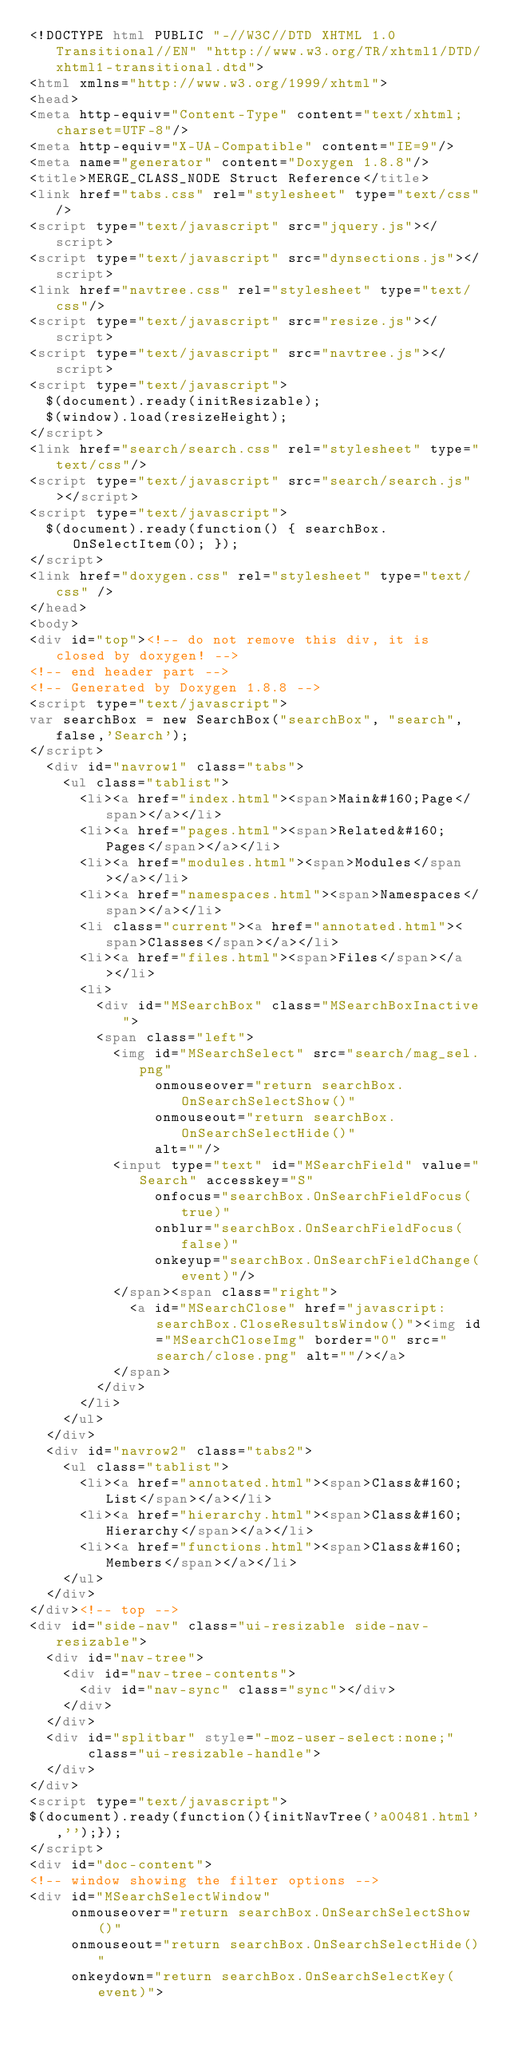Convert code to text. <code><loc_0><loc_0><loc_500><loc_500><_HTML_><!DOCTYPE html PUBLIC "-//W3C//DTD XHTML 1.0 Transitional//EN" "http://www.w3.org/TR/xhtml1/DTD/xhtml1-transitional.dtd">
<html xmlns="http://www.w3.org/1999/xhtml">
<head>
<meta http-equiv="Content-Type" content="text/xhtml;charset=UTF-8"/>
<meta http-equiv="X-UA-Compatible" content="IE=9"/>
<meta name="generator" content="Doxygen 1.8.8"/>
<title>MERGE_CLASS_NODE Struct Reference</title>
<link href="tabs.css" rel="stylesheet" type="text/css"/>
<script type="text/javascript" src="jquery.js"></script>
<script type="text/javascript" src="dynsections.js"></script>
<link href="navtree.css" rel="stylesheet" type="text/css"/>
<script type="text/javascript" src="resize.js"></script>
<script type="text/javascript" src="navtree.js"></script>
<script type="text/javascript">
  $(document).ready(initResizable);
  $(window).load(resizeHeight);
</script>
<link href="search/search.css" rel="stylesheet" type="text/css"/>
<script type="text/javascript" src="search/search.js"></script>
<script type="text/javascript">
  $(document).ready(function() { searchBox.OnSelectItem(0); });
</script>
<link href="doxygen.css" rel="stylesheet" type="text/css" />
</head>
<body>
<div id="top"><!-- do not remove this div, it is closed by doxygen! -->
<!-- end header part -->
<!-- Generated by Doxygen 1.8.8 -->
<script type="text/javascript">
var searchBox = new SearchBox("searchBox", "search",false,'Search');
</script>
  <div id="navrow1" class="tabs">
    <ul class="tablist">
      <li><a href="index.html"><span>Main&#160;Page</span></a></li>
      <li><a href="pages.html"><span>Related&#160;Pages</span></a></li>
      <li><a href="modules.html"><span>Modules</span></a></li>
      <li><a href="namespaces.html"><span>Namespaces</span></a></li>
      <li class="current"><a href="annotated.html"><span>Classes</span></a></li>
      <li><a href="files.html"><span>Files</span></a></li>
      <li>
        <div id="MSearchBox" class="MSearchBoxInactive">
        <span class="left">
          <img id="MSearchSelect" src="search/mag_sel.png"
               onmouseover="return searchBox.OnSearchSelectShow()"
               onmouseout="return searchBox.OnSearchSelectHide()"
               alt=""/>
          <input type="text" id="MSearchField" value="Search" accesskey="S"
               onfocus="searchBox.OnSearchFieldFocus(true)" 
               onblur="searchBox.OnSearchFieldFocus(false)" 
               onkeyup="searchBox.OnSearchFieldChange(event)"/>
          </span><span class="right">
            <a id="MSearchClose" href="javascript:searchBox.CloseResultsWindow()"><img id="MSearchCloseImg" border="0" src="search/close.png" alt=""/></a>
          </span>
        </div>
      </li>
    </ul>
  </div>
  <div id="navrow2" class="tabs2">
    <ul class="tablist">
      <li><a href="annotated.html"><span>Class&#160;List</span></a></li>
      <li><a href="hierarchy.html"><span>Class&#160;Hierarchy</span></a></li>
      <li><a href="functions.html"><span>Class&#160;Members</span></a></li>
    </ul>
  </div>
</div><!-- top -->
<div id="side-nav" class="ui-resizable side-nav-resizable">
  <div id="nav-tree">
    <div id="nav-tree-contents">
      <div id="nav-sync" class="sync"></div>
    </div>
  </div>
  <div id="splitbar" style="-moz-user-select:none;" 
       class="ui-resizable-handle">
  </div>
</div>
<script type="text/javascript">
$(document).ready(function(){initNavTree('a00481.html','');});
</script>
<div id="doc-content">
<!-- window showing the filter options -->
<div id="MSearchSelectWindow"
     onmouseover="return searchBox.OnSearchSelectShow()"
     onmouseout="return searchBox.OnSearchSelectHide()"
     onkeydown="return searchBox.OnSearchSelectKey(event)"></code> 